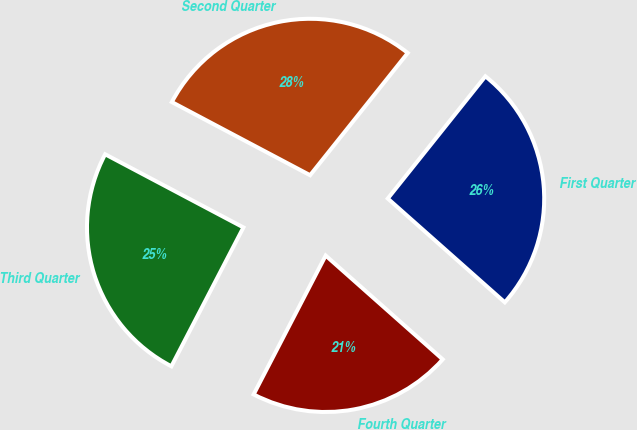Convert chart to OTSL. <chart><loc_0><loc_0><loc_500><loc_500><pie_chart><fcel>First Quarter<fcel>Second Quarter<fcel>Third Quarter<fcel>Fourth Quarter<nl><fcel>25.82%<fcel>27.98%<fcel>25.13%<fcel>21.07%<nl></chart> 